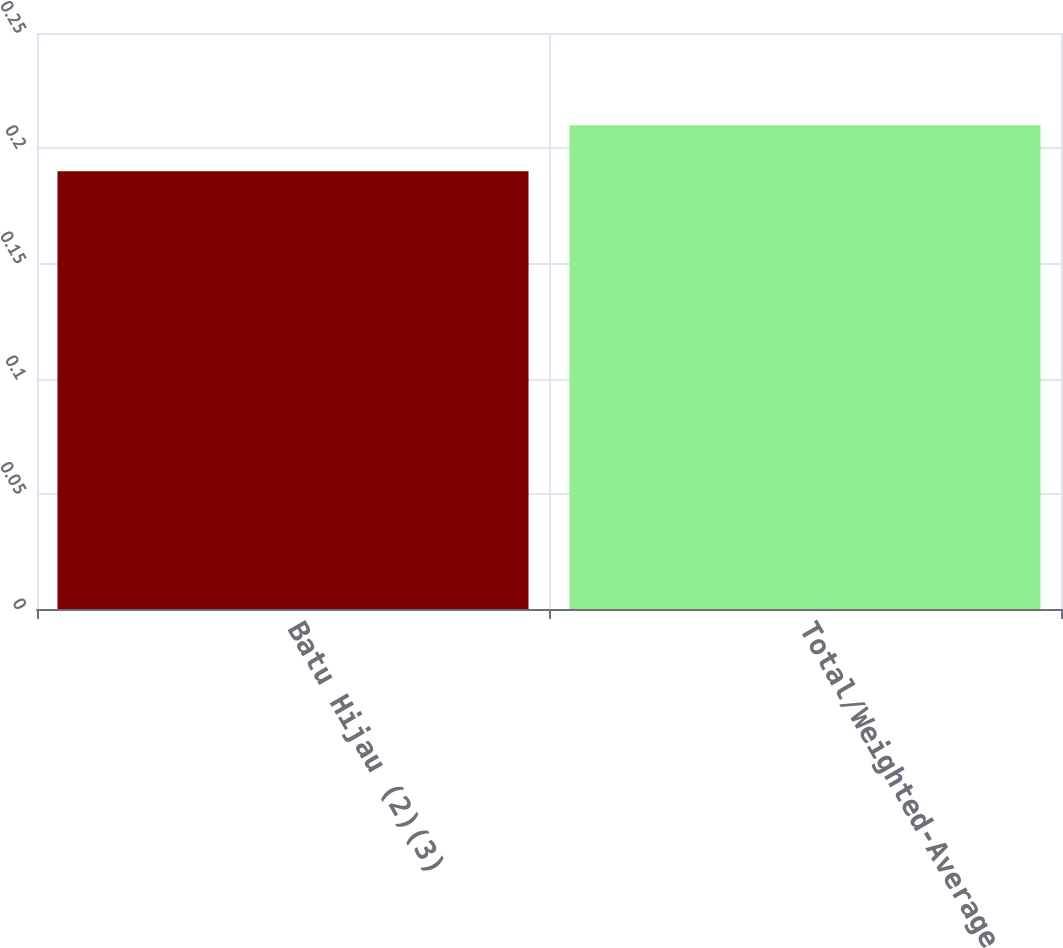Convert chart to OTSL. <chart><loc_0><loc_0><loc_500><loc_500><bar_chart><fcel>Batu Hijau (2)(3)<fcel>Total/Weighted-Average<nl><fcel>0.19<fcel>0.21<nl></chart> 